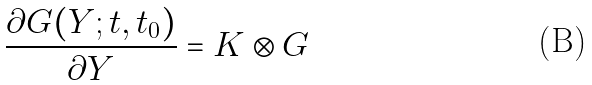<formula> <loc_0><loc_0><loc_500><loc_500>\frac { \partial G ( Y ; t , t _ { 0 } ) } { \partial Y } = K \otimes G</formula> 